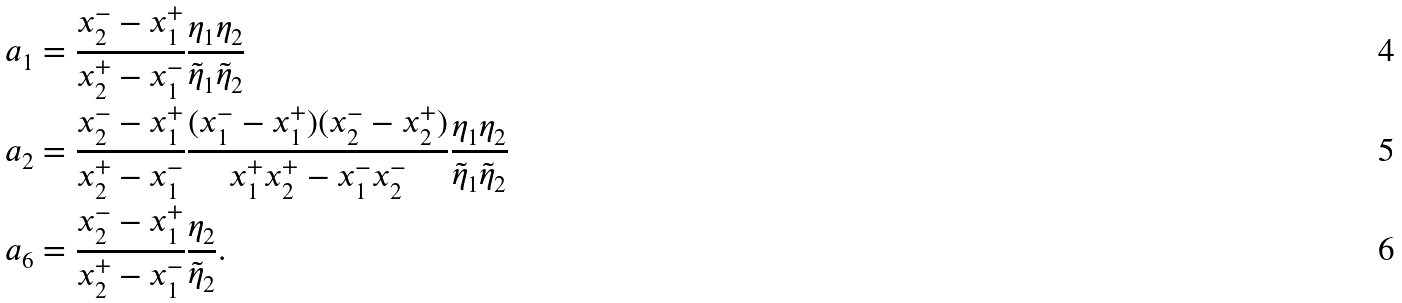<formula> <loc_0><loc_0><loc_500><loc_500>a _ { 1 } & = \frac { x _ { 2 } ^ { - } - x _ { 1 } ^ { + } } { x _ { 2 } ^ { + } - x _ { 1 } ^ { - } } \frac { \eta _ { 1 } \eta _ { 2 } } { \tilde { \eta } _ { 1 } \tilde { \eta } _ { 2 } } \\ a _ { 2 } & = \frac { x _ { 2 } ^ { - } - x _ { 1 } ^ { + } } { x _ { 2 } ^ { + } - x _ { 1 } ^ { - } } \frac { ( x _ { 1 } ^ { - } - x _ { 1 } ^ { + } ) ( x _ { 2 } ^ { - } - x _ { 2 } ^ { + } ) } { x _ { 1 } ^ { + } x _ { 2 } ^ { + } - x _ { 1 } ^ { - } x _ { 2 } ^ { - } } \frac { \eta _ { 1 } \eta _ { 2 } } { \tilde { \eta } _ { 1 } \tilde { \eta } _ { 2 } } \\ a _ { 6 } & = \frac { x _ { 2 } ^ { - } - x _ { 1 } ^ { + } } { x _ { 2 } ^ { + } - x _ { 1 } ^ { - } } \frac { \eta _ { 2 } } { \tilde { \eta } _ { 2 } } .</formula> 